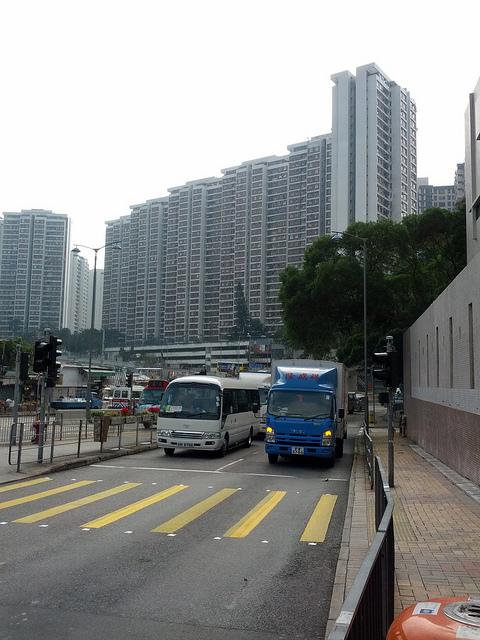Is the street lined with trees?
Concise answer only. No. What color are stripes on the road?
Concise answer only. Yellow. Are the headlights engaged on both vehicles?
Answer briefly. No. 